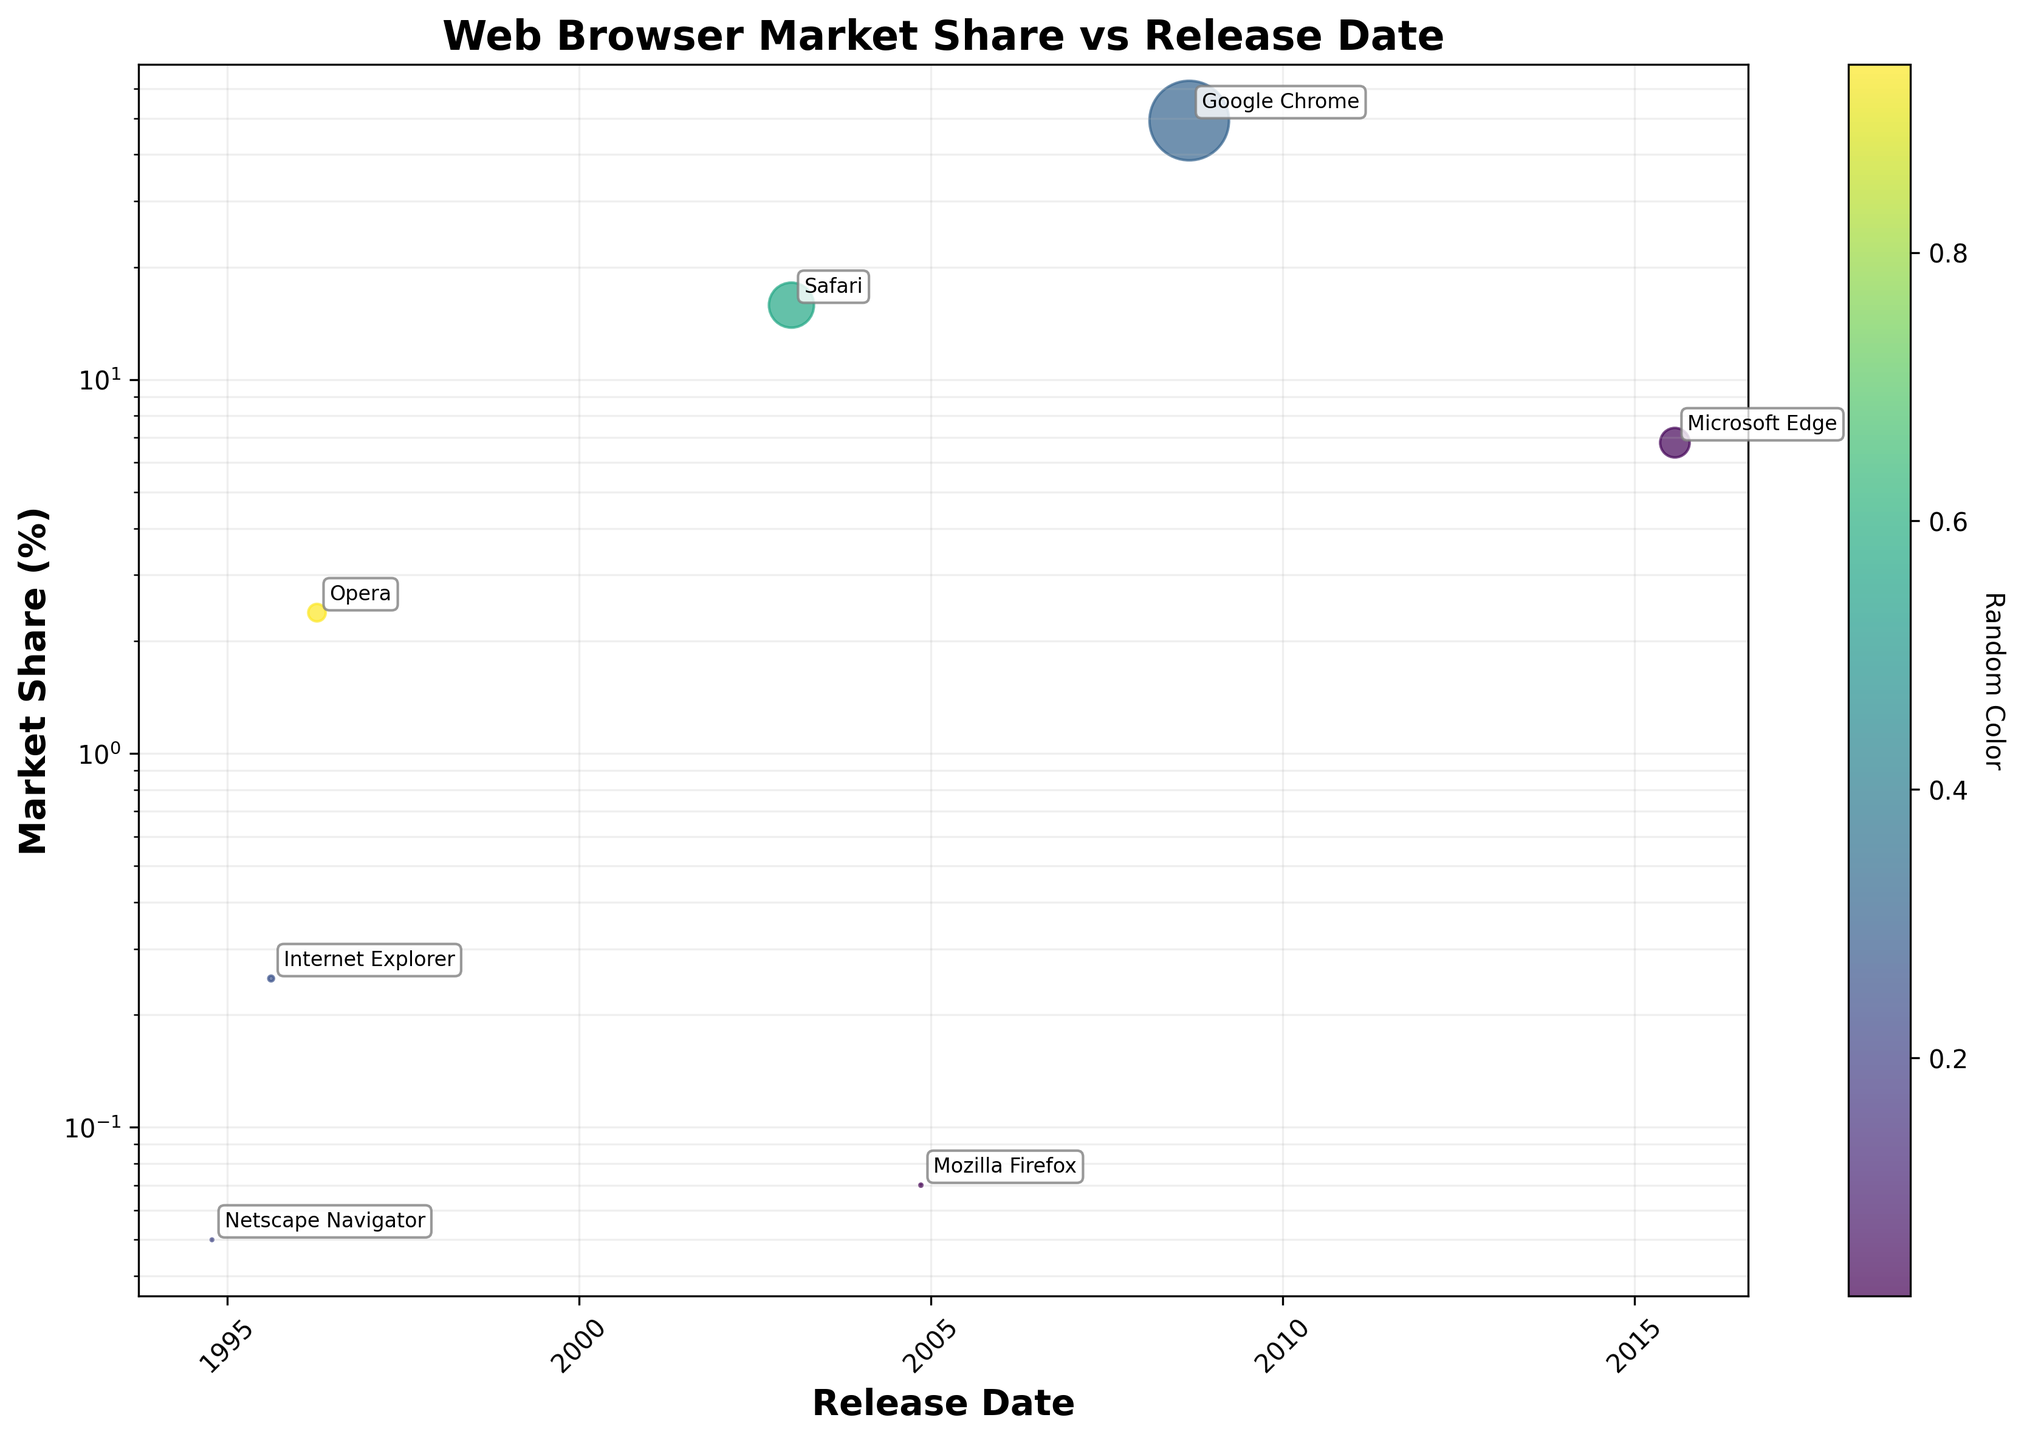What's the title of the figure? The title is typically displayed at the top of a figure. Here, it reads "Web Browser Market Share vs Release Date".
Answer: Web Browser Market Share vs Release Date How many data points are there on the scatter plot? You can count the number of points labeled with each browser name, which are 7 in total.
Answer: 7 Which web browser has the highest market share? Google's Chrome has the highest market share, as evidenced by the size of its data point and the annotated information.
Answer: Google Chrome Which browser was released most recently? By looking at the x-axis and the positions of annotations, Microsoft Edge, released in 2015, is the most recent.
Answer: Microsoft Edge What is the range of release dates depicted on the x-axis? The x-axis shows dates from around 1994 to 2015, as indicated by the labeled ticks.
Answer: 1994 to 2015 Which browser has the smallest market share, and what is it? Netscape Navigator has the smallest market share, as seen by the smallest data point and its annotation.
Answer: Netscape Navigator with 0.05% What is the market share difference between Safari and Mozilla Firefox? The market share of Safari is 15.82% and Mozilla Firefox is 7%. The difference is 15.82 - 0.07 = 15.75%.
Answer: 15.75% Which browsers were released before the year 2000? Browsers released before 2000 are Netscape Navigator (1994), Internet Explorer (1995), and Opera (1996).
Answer: Netscape Navigator, Internet Explorer, Opera Which browser has a release date that's closest to the year 2000? By observing the x-axis, Opera, released in 1996, is the browser closest to 2000.
Answer: Opera Compare the market shares of Internet Explorer and Microsoft Edge. Which one has a higher market share? Internet Explorer at 25% has a higher market share compared to Microsoft Edge's 6.78%.
Answer: Internet Explorer 